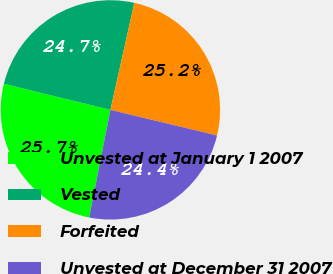<chart> <loc_0><loc_0><loc_500><loc_500><pie_chart><fcel>Unvested at January 1 2007<fcel>Vested<fcel>Forfeited<fcel>Unvested at December 31 2007<nl><fcel>25.73%<fcel>24.67%<fcel>25.25%<fcel>24.35%<nl></chart> 